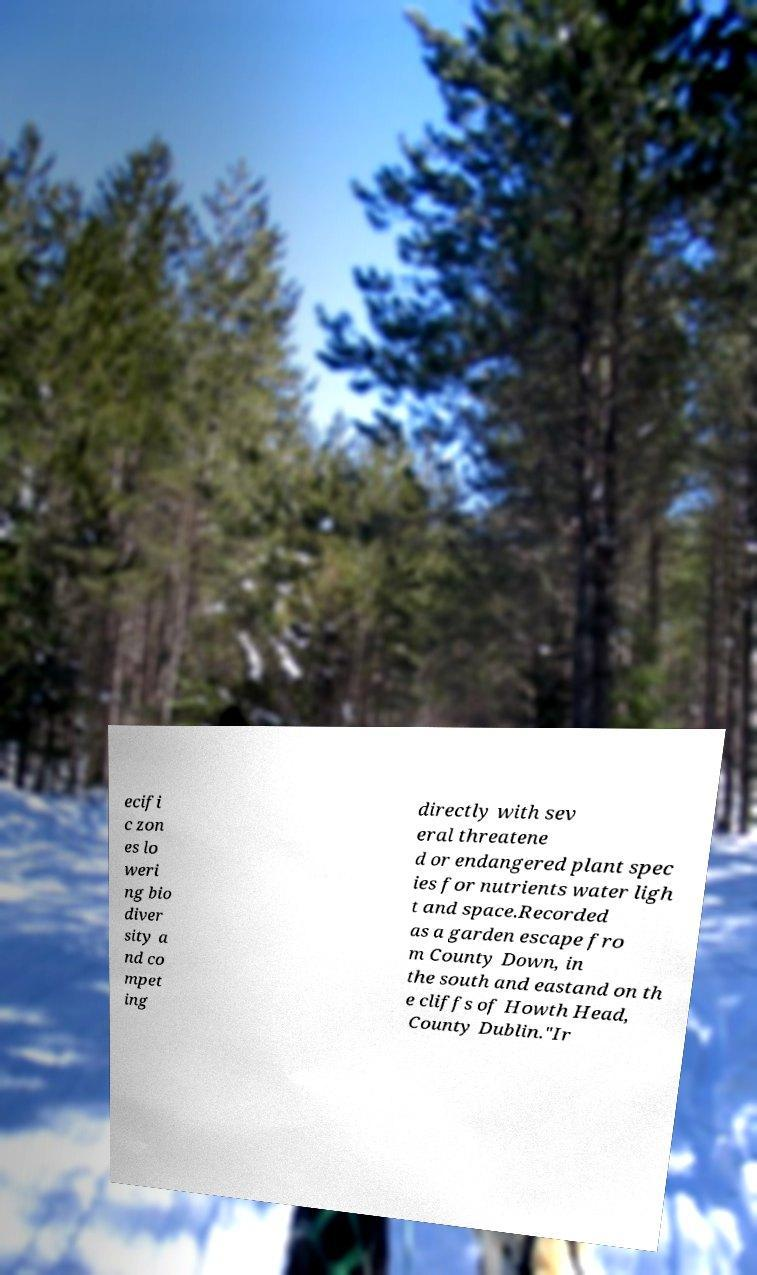Please identify and transcribe the text found in this image. ecifi c zon es lo weri ng bio diver sity a nd co mpet ing directly with sev eral threatene d or endangered plant spec ies for nutrients water ligh t and space.Recorded as a garden escape fro m County Down, in the south and eastand on th e cliffs of Howth Head, County Dublin."Ir 